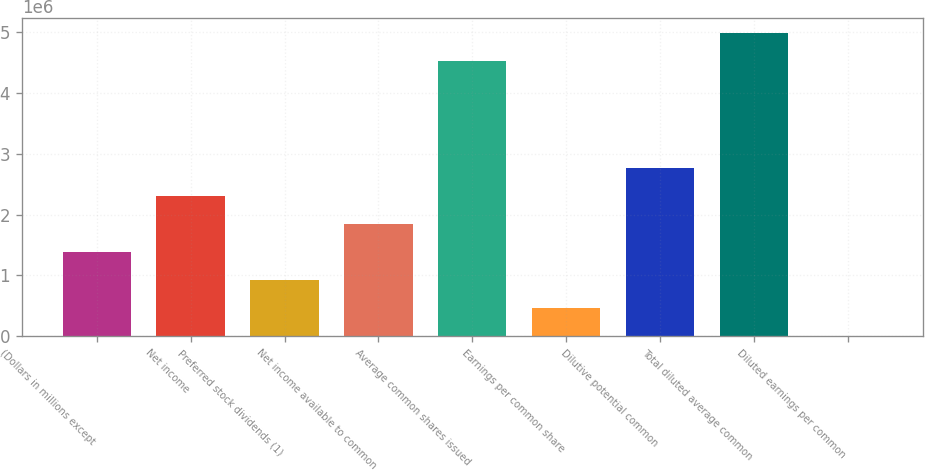Convert chart to OTSL. <chart><loc_0><loc_0><loc_500><loc_500><bar_chart><fcel>(Dollars in millions except<fcel>Net income<fcel>Preferred stock dividends (1)<fcel>Net income available to common<fcel>Average common shares issued<fcel>Earnings per common share<fcel>Dilutive potential common<fcel>Total diluted average common<fcel>Diluted earnings per common<nl><fcel>1.37877e+06<fcel>2.29795e+06<fcel>919183<fcel>1.83836e+06<fcel>4.52664e+06<fcel>459594<fcel>2.75754e+06<fcel>4.98623e+06<fcel>4.59<nl></chart> 